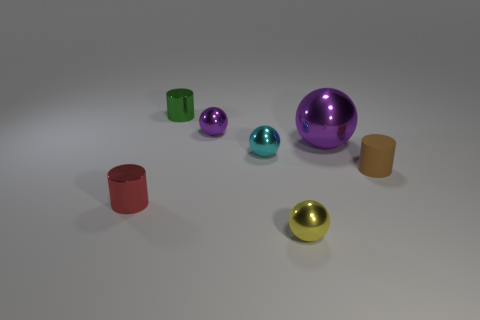Is there another object of the same color as the big thing?
Provide a succinct answer. Yes. What number of small purple shiny balls are there?
Ensure brevity in your answer.  1. What is the small cylinder that is right of the purple ball on the left side of the metal ball in front of the red shiny object made of?
Make the answer very short. Rubber. Are there any other tiny green things that have the same material as the tiny green object?
Ensure brevity in your answer.  No. Is the material of the small brown cylinder the same as the tiny purple ball?
Provide a succinct answer. No. How many cylinders are either tiny metal objects or large purple metallic objects?
Ensure brevity in your answer.  2. There is another large sphere that is the same material as the yellow sphere; what color is it?
Ensure brevity in your answer.  Purple. Are there fewer purple cylinders than purple objects?
Offer a very short reply. Yes. Does the small metal object left of the tiny green object have the same shape as the thing behind the tiny purple thing?
Your answer should be compact. Yes. How many things are tiny things or brown rubber blocks?
Keep it short and to the point. 6. 